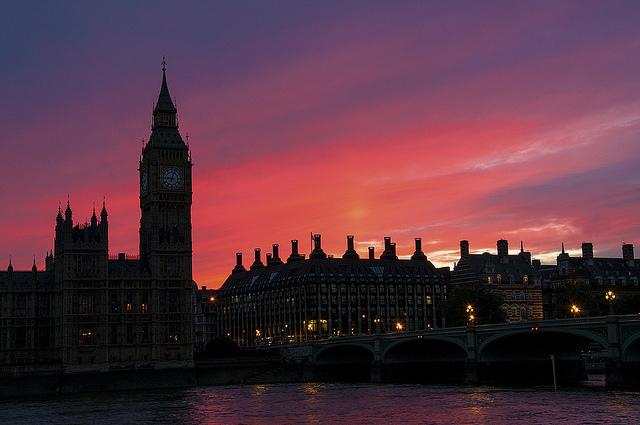What famous building is in the distance?
Quick response, please. Big ben. Is this a colorful picture?
Give a very brief answer. Yes. Can you see the moon in the sky?
Write a very short answer. No. What country is this in?
Answer briefly. England. What is this place?
Answer briefly. London. Is this a church?
Give a very brief answer. No. Is this a competition?
Give a very brief answer. No. Does the sun set in the west or east?
Answer briefly. West. What time does the clock say?
Give a very brief answer. 9:05. What is the monument in the background?
Quick response, please. Big ben. What is the scene in the background?
Be succinct. London. Is it sunrise or sunset?
Short answer required. Sunset. What is the color of the cloud?
Keep it brief. Red. What color is the water?
Keep it brief. Dark. Is it daytime?
Short answer required. No. 